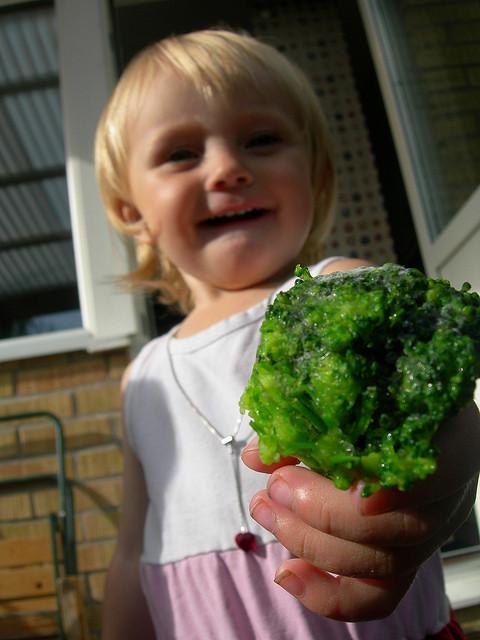What is she holding?
Short answer required. Broccoli. Is this in someone's home?
Quick response, please. Yes. Does this little girl have on jewelry?
Give a very brief answer. Yes. Is the girl blonde?
Write a very short answer. Yes. 